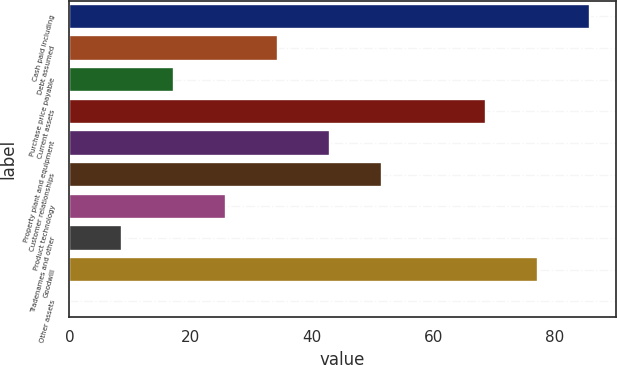Convert chart to OTSL. <chart><loc_0><loc_0><loc_500><loc_500><bar_chart><fcel>Cash paid including<fcel>Debt assumed<fcel>Purchase price payable<fcel>Current assets<fcel>Property plant and equipment<fcel>Customer relationships<fcel>Product technology<fcel>Tradenames and other<fcel>Goodwill<fcel>Other assets<nl><fcel>85.8<fcel>34.38<fcel>17.24<fcel>68.66<fcel>42.95<fcel>51.52<fcel>25.81<fcel>8.67<fcel>77.23<fcel>0.1<nl></chart> 